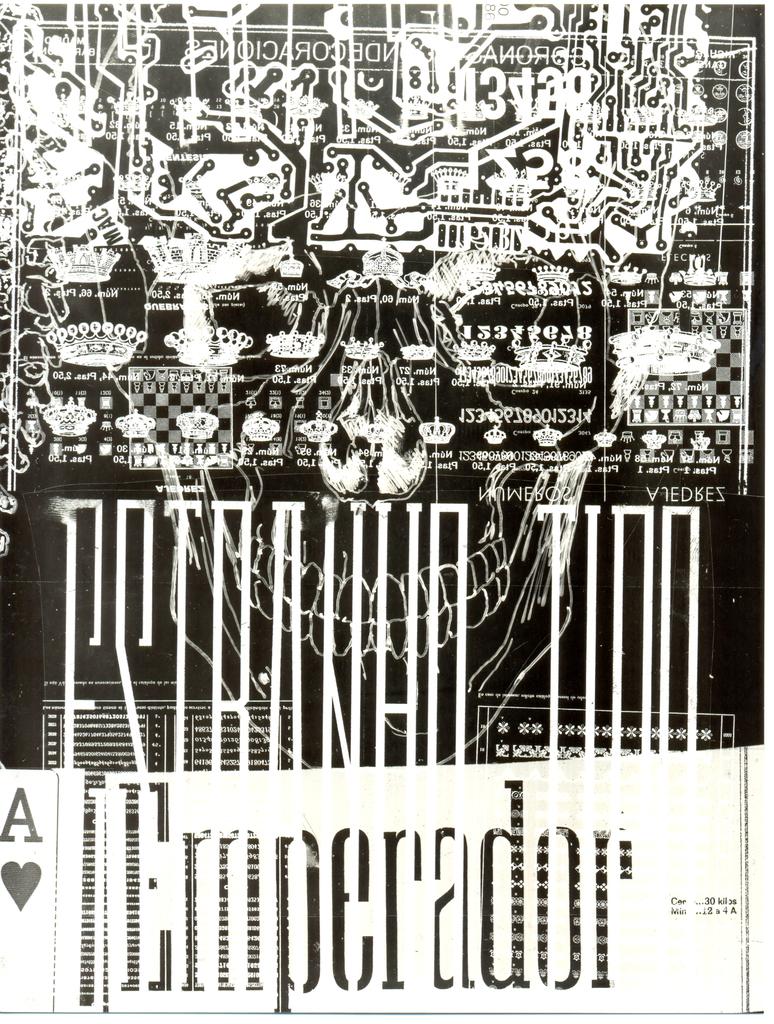What poker card is shown in the bottom left corner of this picture?
Provide a short and direct response. Ace of hearts. 